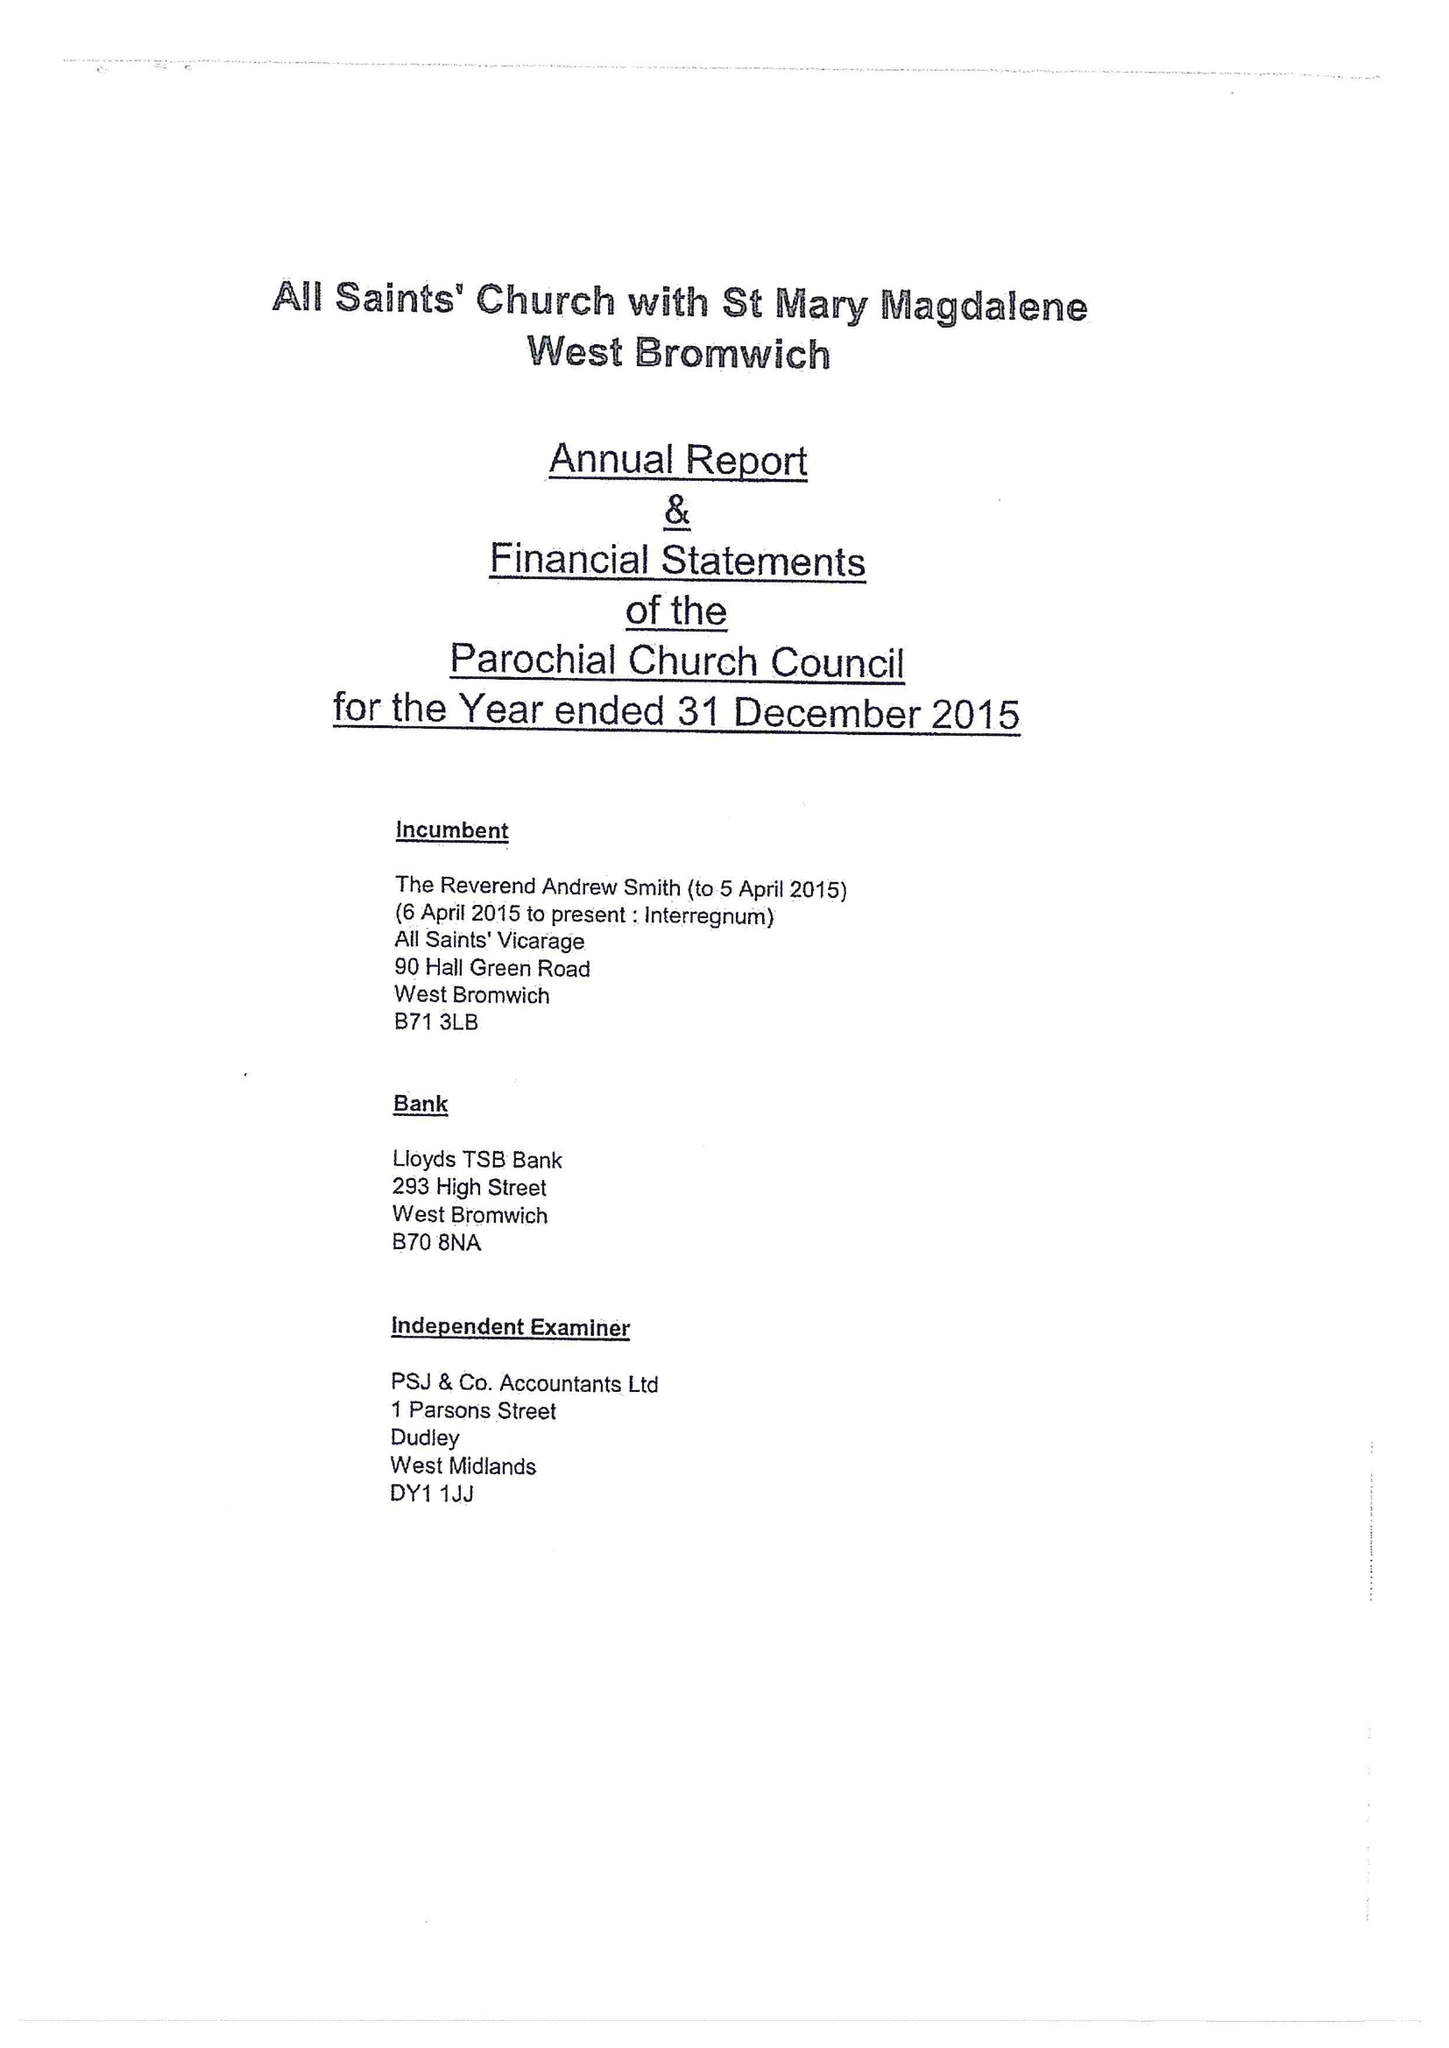What is the value for the income_annually_in_british_pounds?
Answer the question using a single word or phrase. 169035.00 